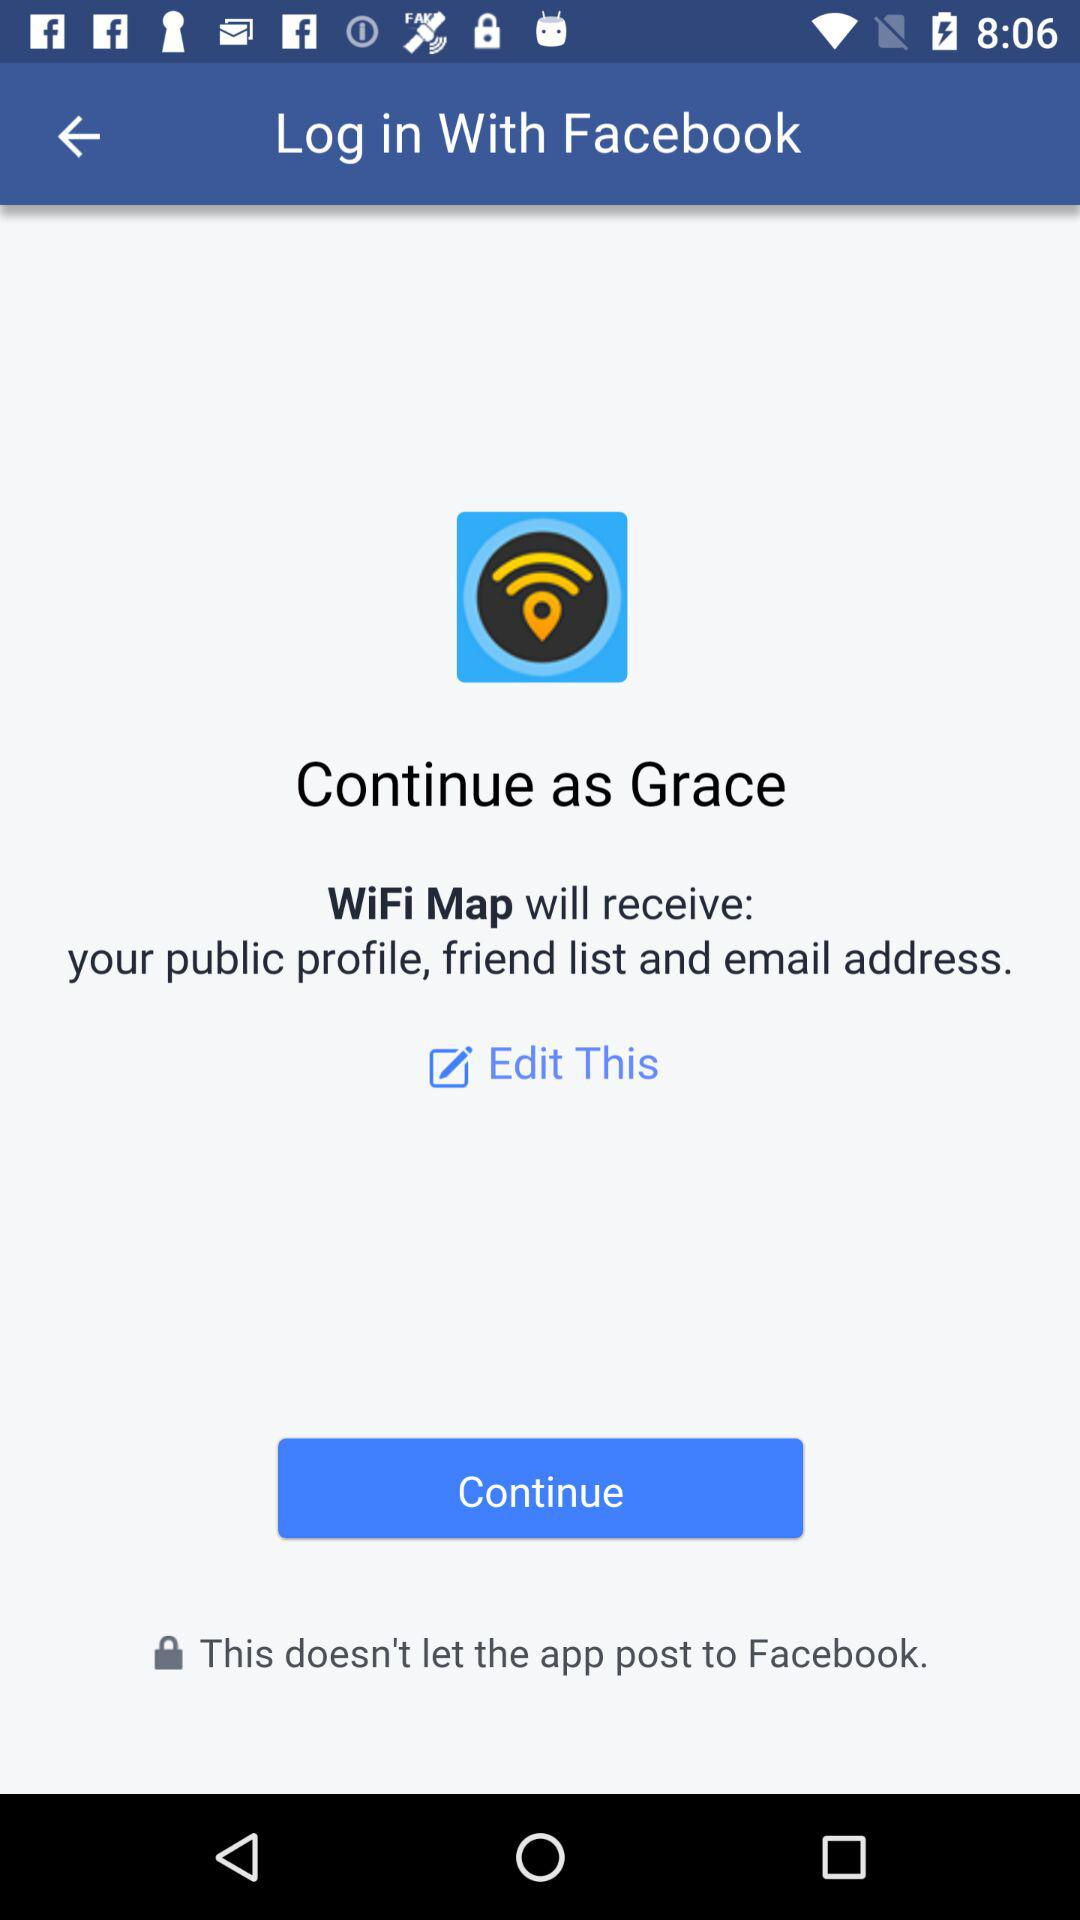What is the user name? The user name is "Grace". 